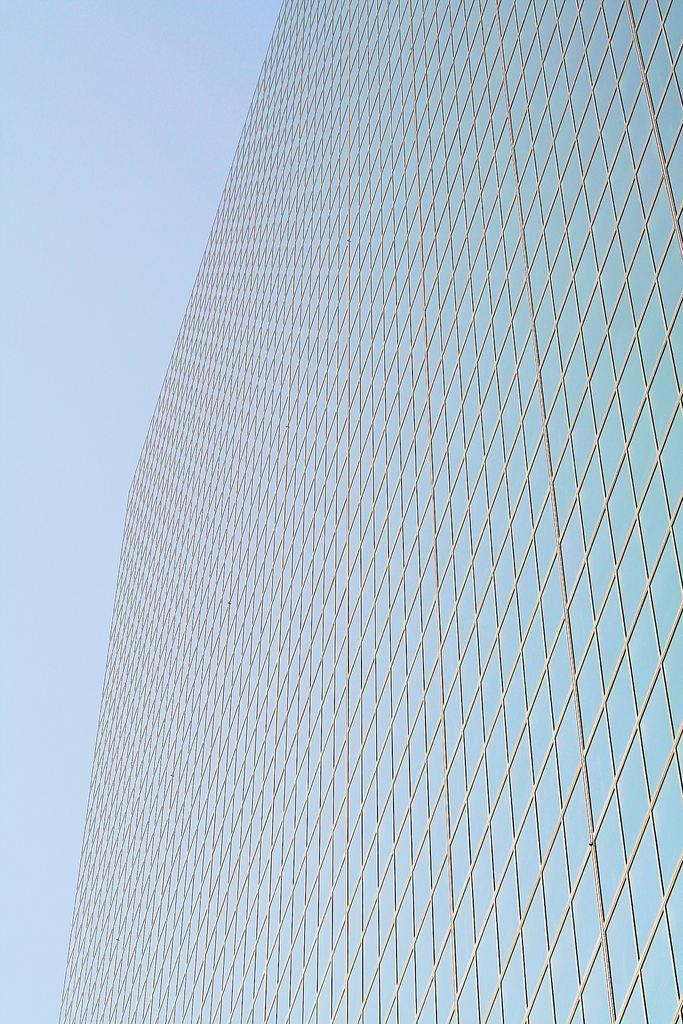What structure is located on the right side of the image? There is a building on the right side of the image. What is visible at the top of the image? The sky is visible at the top of the image. How many clocks can be seen hanging from the building in the image? There is no mention of clocks in the image, so it is not possible to determine how many there are. What type of eggs are visible in the image? There are no eggs present in the image. 